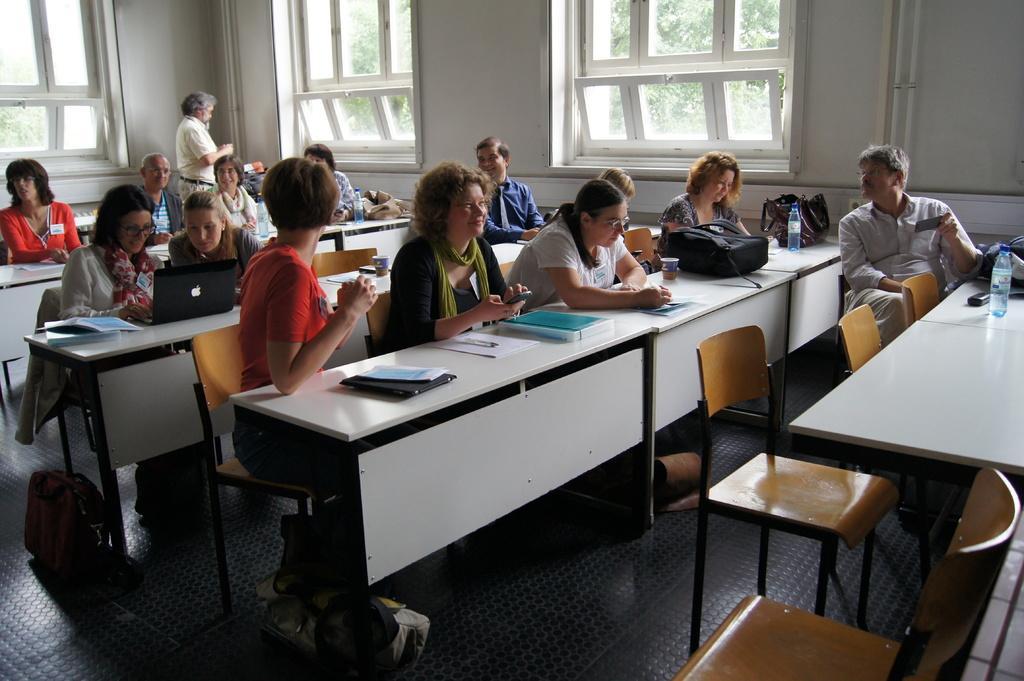Describe this image in one or two sentences. On the background we can see wall and windows. Through window glasses , trees are visible. We can see one man is standing near to the window. We can see all the students sitting on chairs in front of a table and on the table we can see books, papers, laptop, bottle, glasses. This is a floor. 